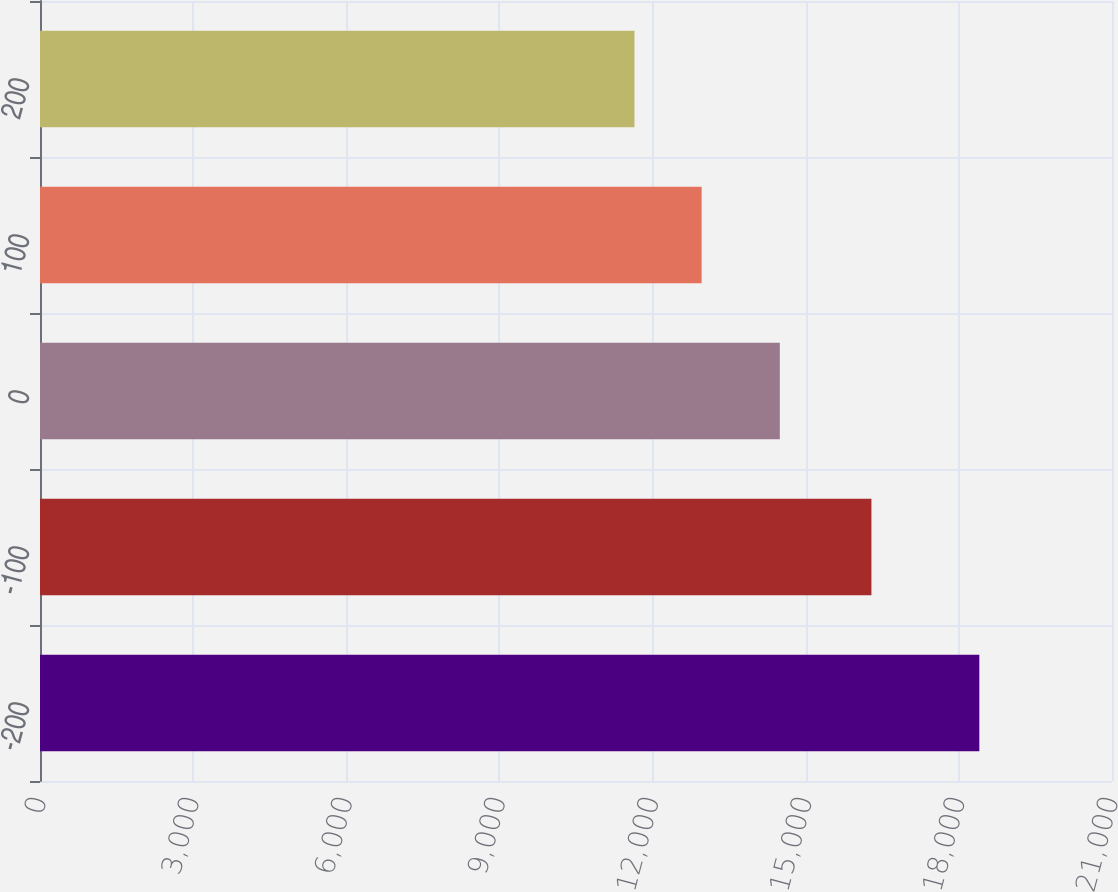Convert chart to OTSL. <chart><loc_0><loc_0><loc_500><loc_500><bar_chart><fcel>-200<fcel>-100<fcel>0<fcel>100<fcel>200<nl><fcel>18401<fcel>16287<fcel>14493<fcel>12961<fcel>11645<nl></chart> 